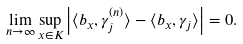Convert formula to latex. <formula><loc_0><loc_0><loc_500><loc_500>\lim _ { n \rightarrow \infty } \sup _ { x \in K } \left | \langle b _ { x } , \gamma _ { j } ^ { ( n ) } \rangle - \langle b _ { x } , \gamma _ { j } \rangle \right | = 0 .</formula> 